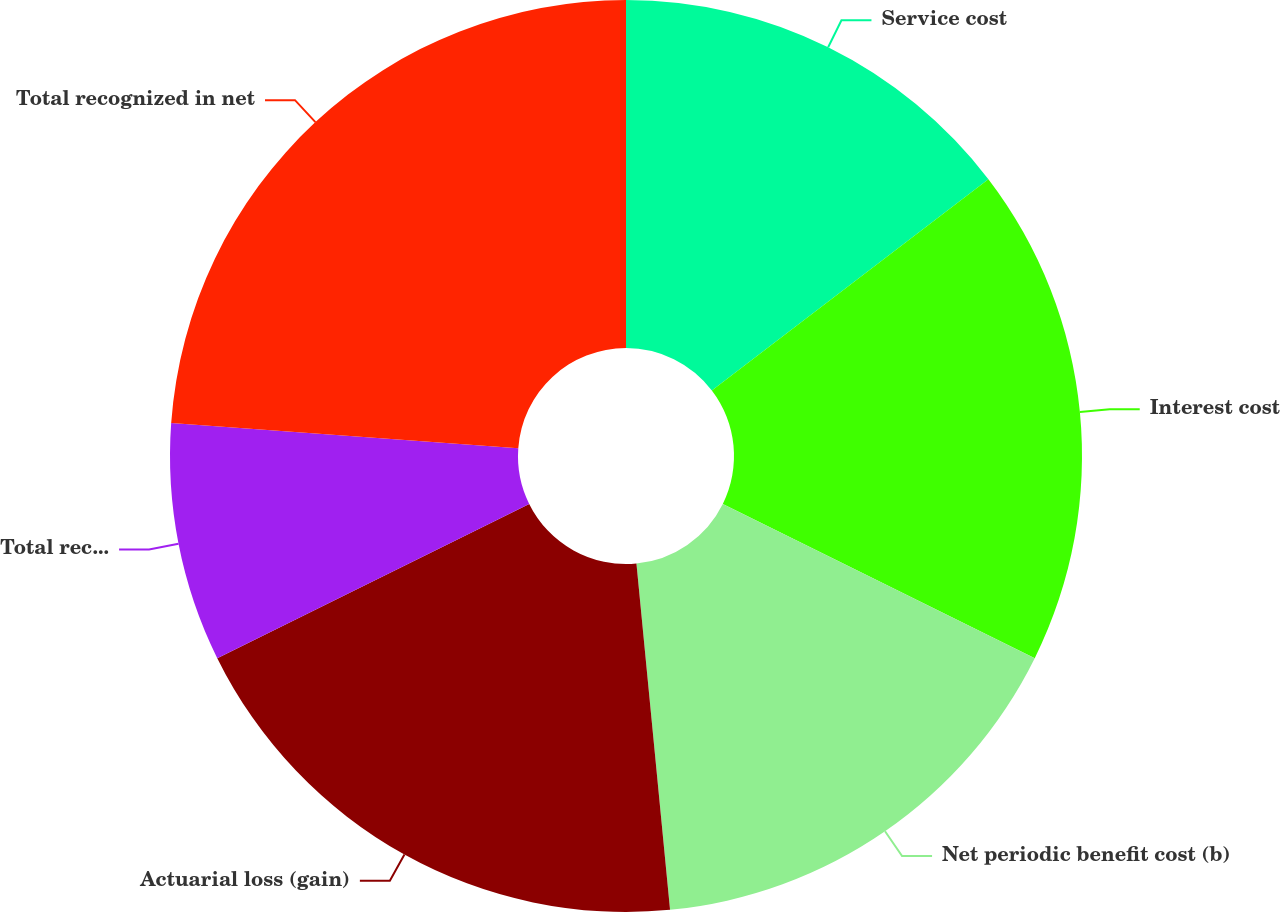Convert chart to OTSL. <chart><loc_0><loc_0><loc_500><loc_500><pie_chart><fcel>Service cost<fcel>Interest cost<fcel>Net periodic benefit cost (b)<fcel>Actuarial loss (gain)<fcel>Total recognized in other<fcel>Total recognized in net<nl><fcel>14.62%<fcel>17.69%<fcel>16.15%<fcel>19.23%<fcel>8.46%<fcel>23.85%<nl></chart> 